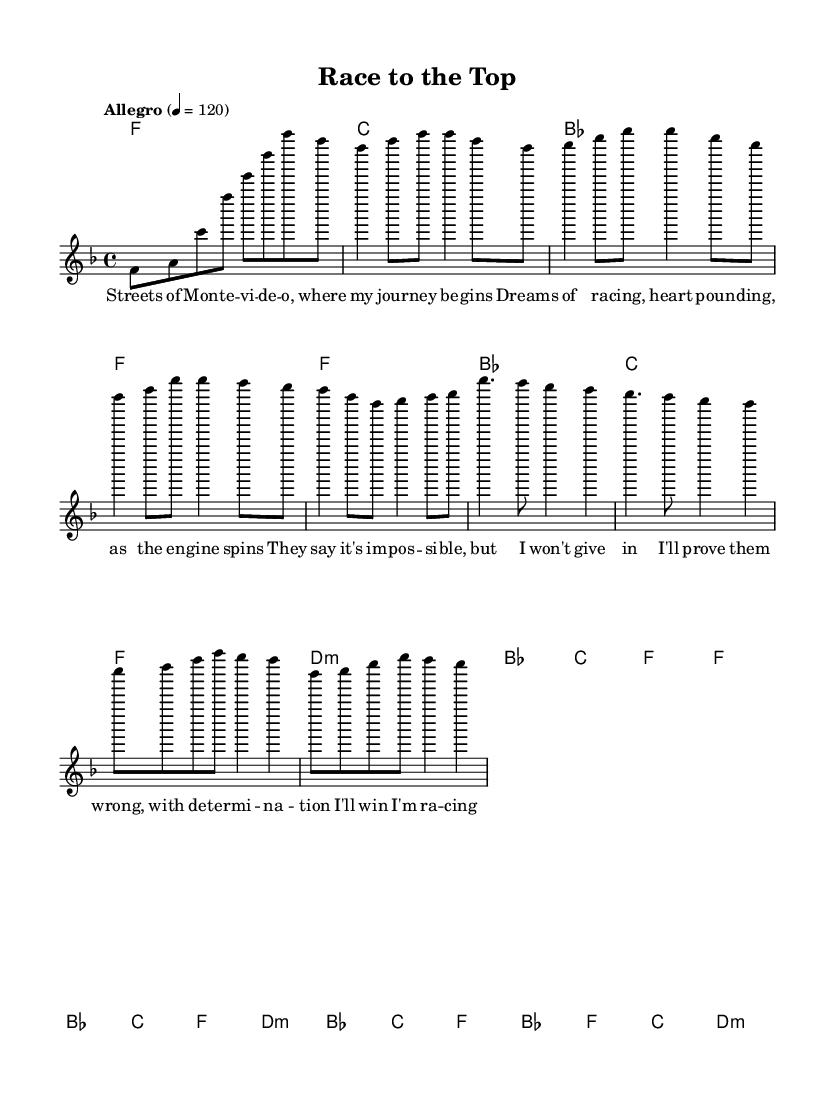What is the key signature of this music? The key signature is F major, which has one flat (B). This is determined by looking at the key command in the global section of the LilyPond code, where it specifies "f \major".
Answer: F major What is the time signature of this music? The time signature is 4/4. This is indicated in the global section of the code where it states "\time 4/4". This means each measure has four beats, and each quarter note is one beat.
Answer: 4/4 What is the tempo marking given for this piece? The tempo marking is "Allegro", which typically indicates a lively pace. This is found in the global section of the code where it states "\tempo 'Allegro' 4 = 120", meaning the beat is set to 120 beats per minute.
Answer: Allegro How many sections are indicated in the score? The score consists of four main sections: Intro, Verse, Pre-chorus, and Chorus. This can be inferred by looking at the structured lyrics and their respective placement in the melody.
Answer: Four What is the main theme expressed in the lyrics? The main theme is about chasing dreams and overcoming obstacles. This can be discerned from the lyrics which speak of racing to the top and proving others wrong, emphasizing determination and success in the face of challenges.
Answer: Chasing dreams Which chord is used in the chorus? The chords used in the chorus are F, B flat, C, and D minor. This is collected from the harmony section in the code, which outlines the chord progression that matches the lyrical phrases.
Answer: F, B flat, C, D minor What rhythmical characteristic is common in up-tempo R&B songs shown here? The rhythmical characteristic is syncopation and a steady beat, which contribute to the upbeat feel of the genre. The melody exhibits varying note lengths and rests, giving a lively and dynamic feel typical of R&B.
Answer: Syncopation 